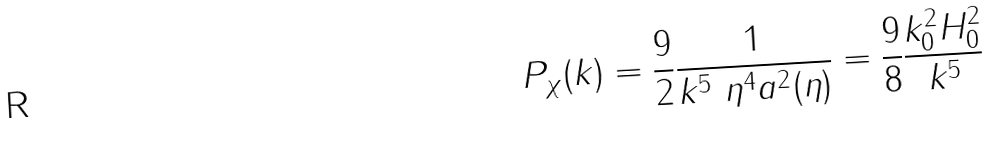Convert formula to latex. <formula><loc_0><loc_0><loc_500><loc_500>P _ { \chi } ( k ) = \frac { 9 } { 2 } \frac { 1 } { k ^ { 5 } \ \eta ^ { 4 } a ^ { 2 } ( \eta ) } = \frac { 9 } { 8 } \frac { k _ { 0 } ^ { 2 } H _ { 0 } ^ { 2 } } { k ^ { 5 } }</formula> 